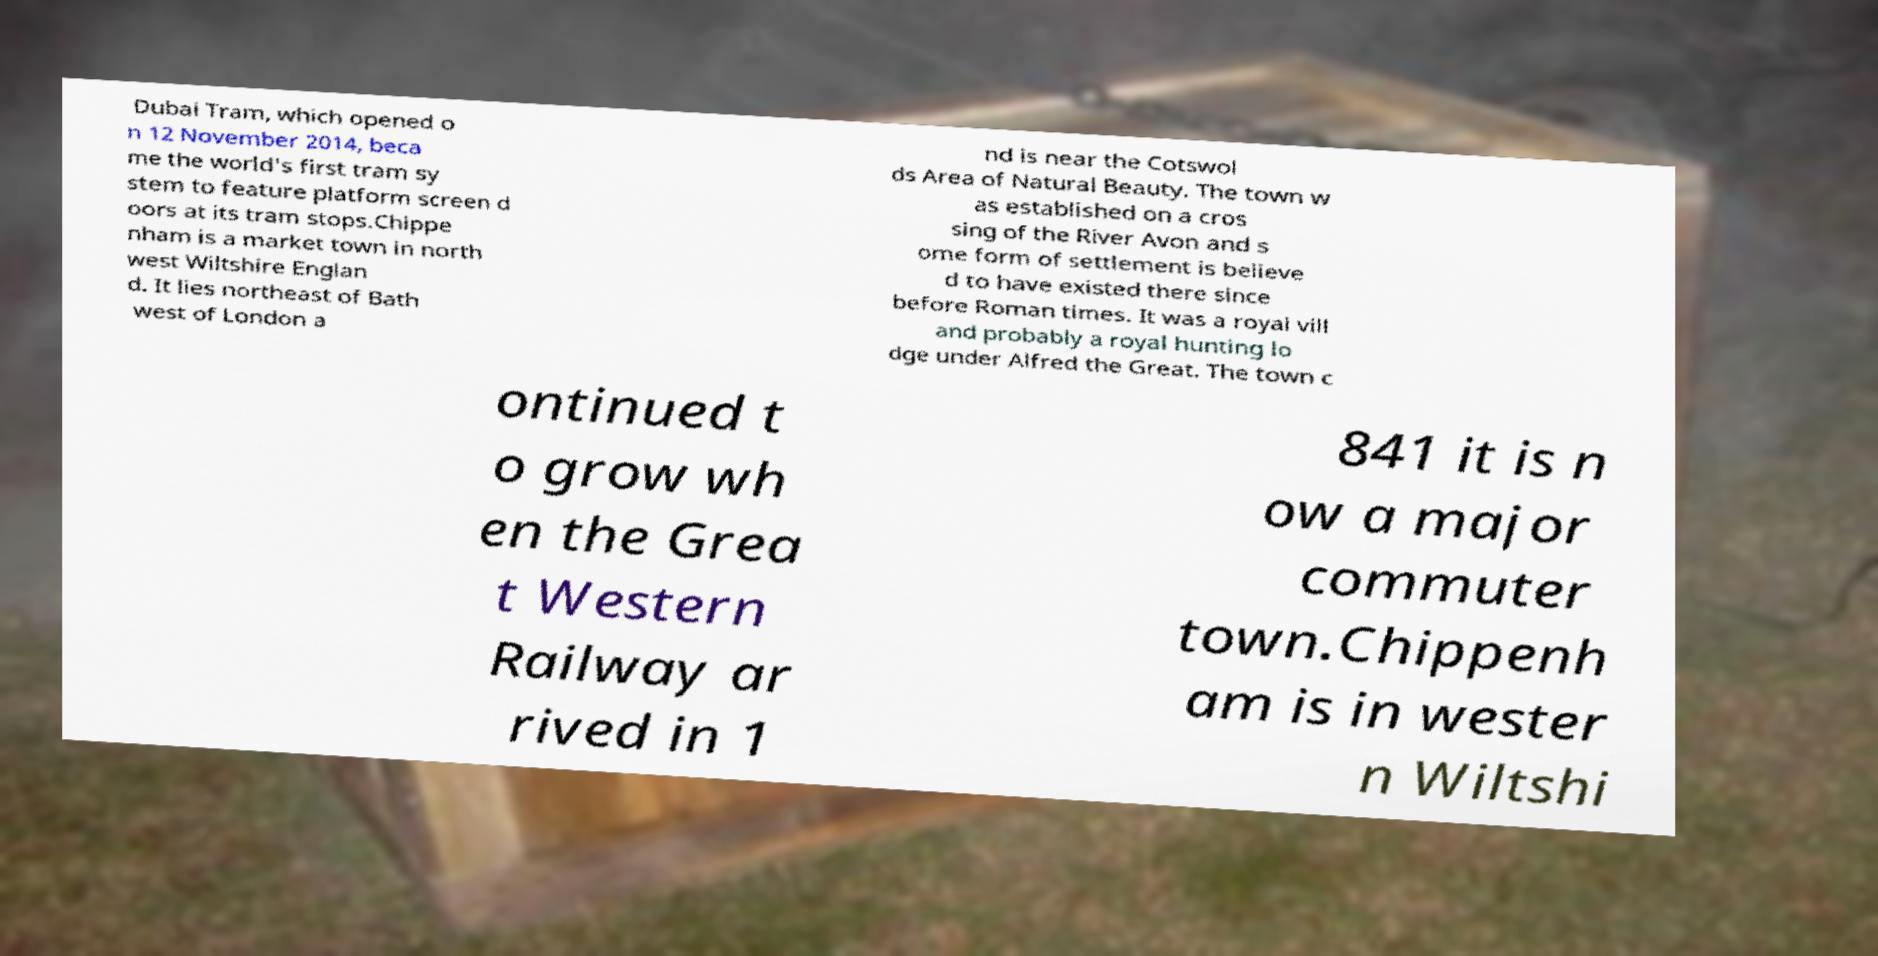Please identify and transcribe the text found in this image. Dubai Tram, which opened o n 12 November 2014, beca me the world's first tram sy stem to feature platform screen d oors at its tram stops.Chippe nham is a market town in north west Wiltshire Englan d. It lies northeast of Bath west of London a nd is near the Cotswol ds Area of Natural Beauty. The town w as established on a cros sing of the River Avon and s ome form of settlement is believe d to have existed there since before Roman times. It was a royal vill and probably a royal hunting lo dge under Alfred the Great. The town c ontinued t o grow wh en the Grea t Western Railway ar rived in 1 841 it is n ow a major commuter town.Chippenh am is in wester n Wiltshi 